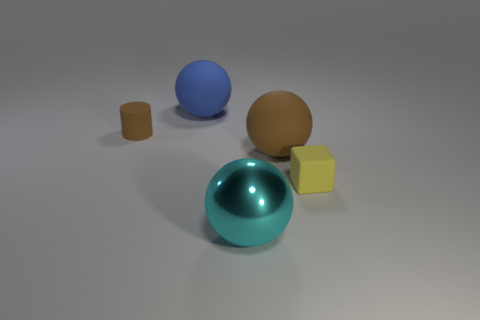If this image were part of an art installation, what themes might it represent? This composition could represent themes of balance and contrast in an art installation. The variation in shapes (spheres, cylinder, cube) and finishes (matte, glossy) juxtaposed against a neutral background could evoke contemplation on the diversity and unity of elements within a space, as well as the interaction of light and texture. 